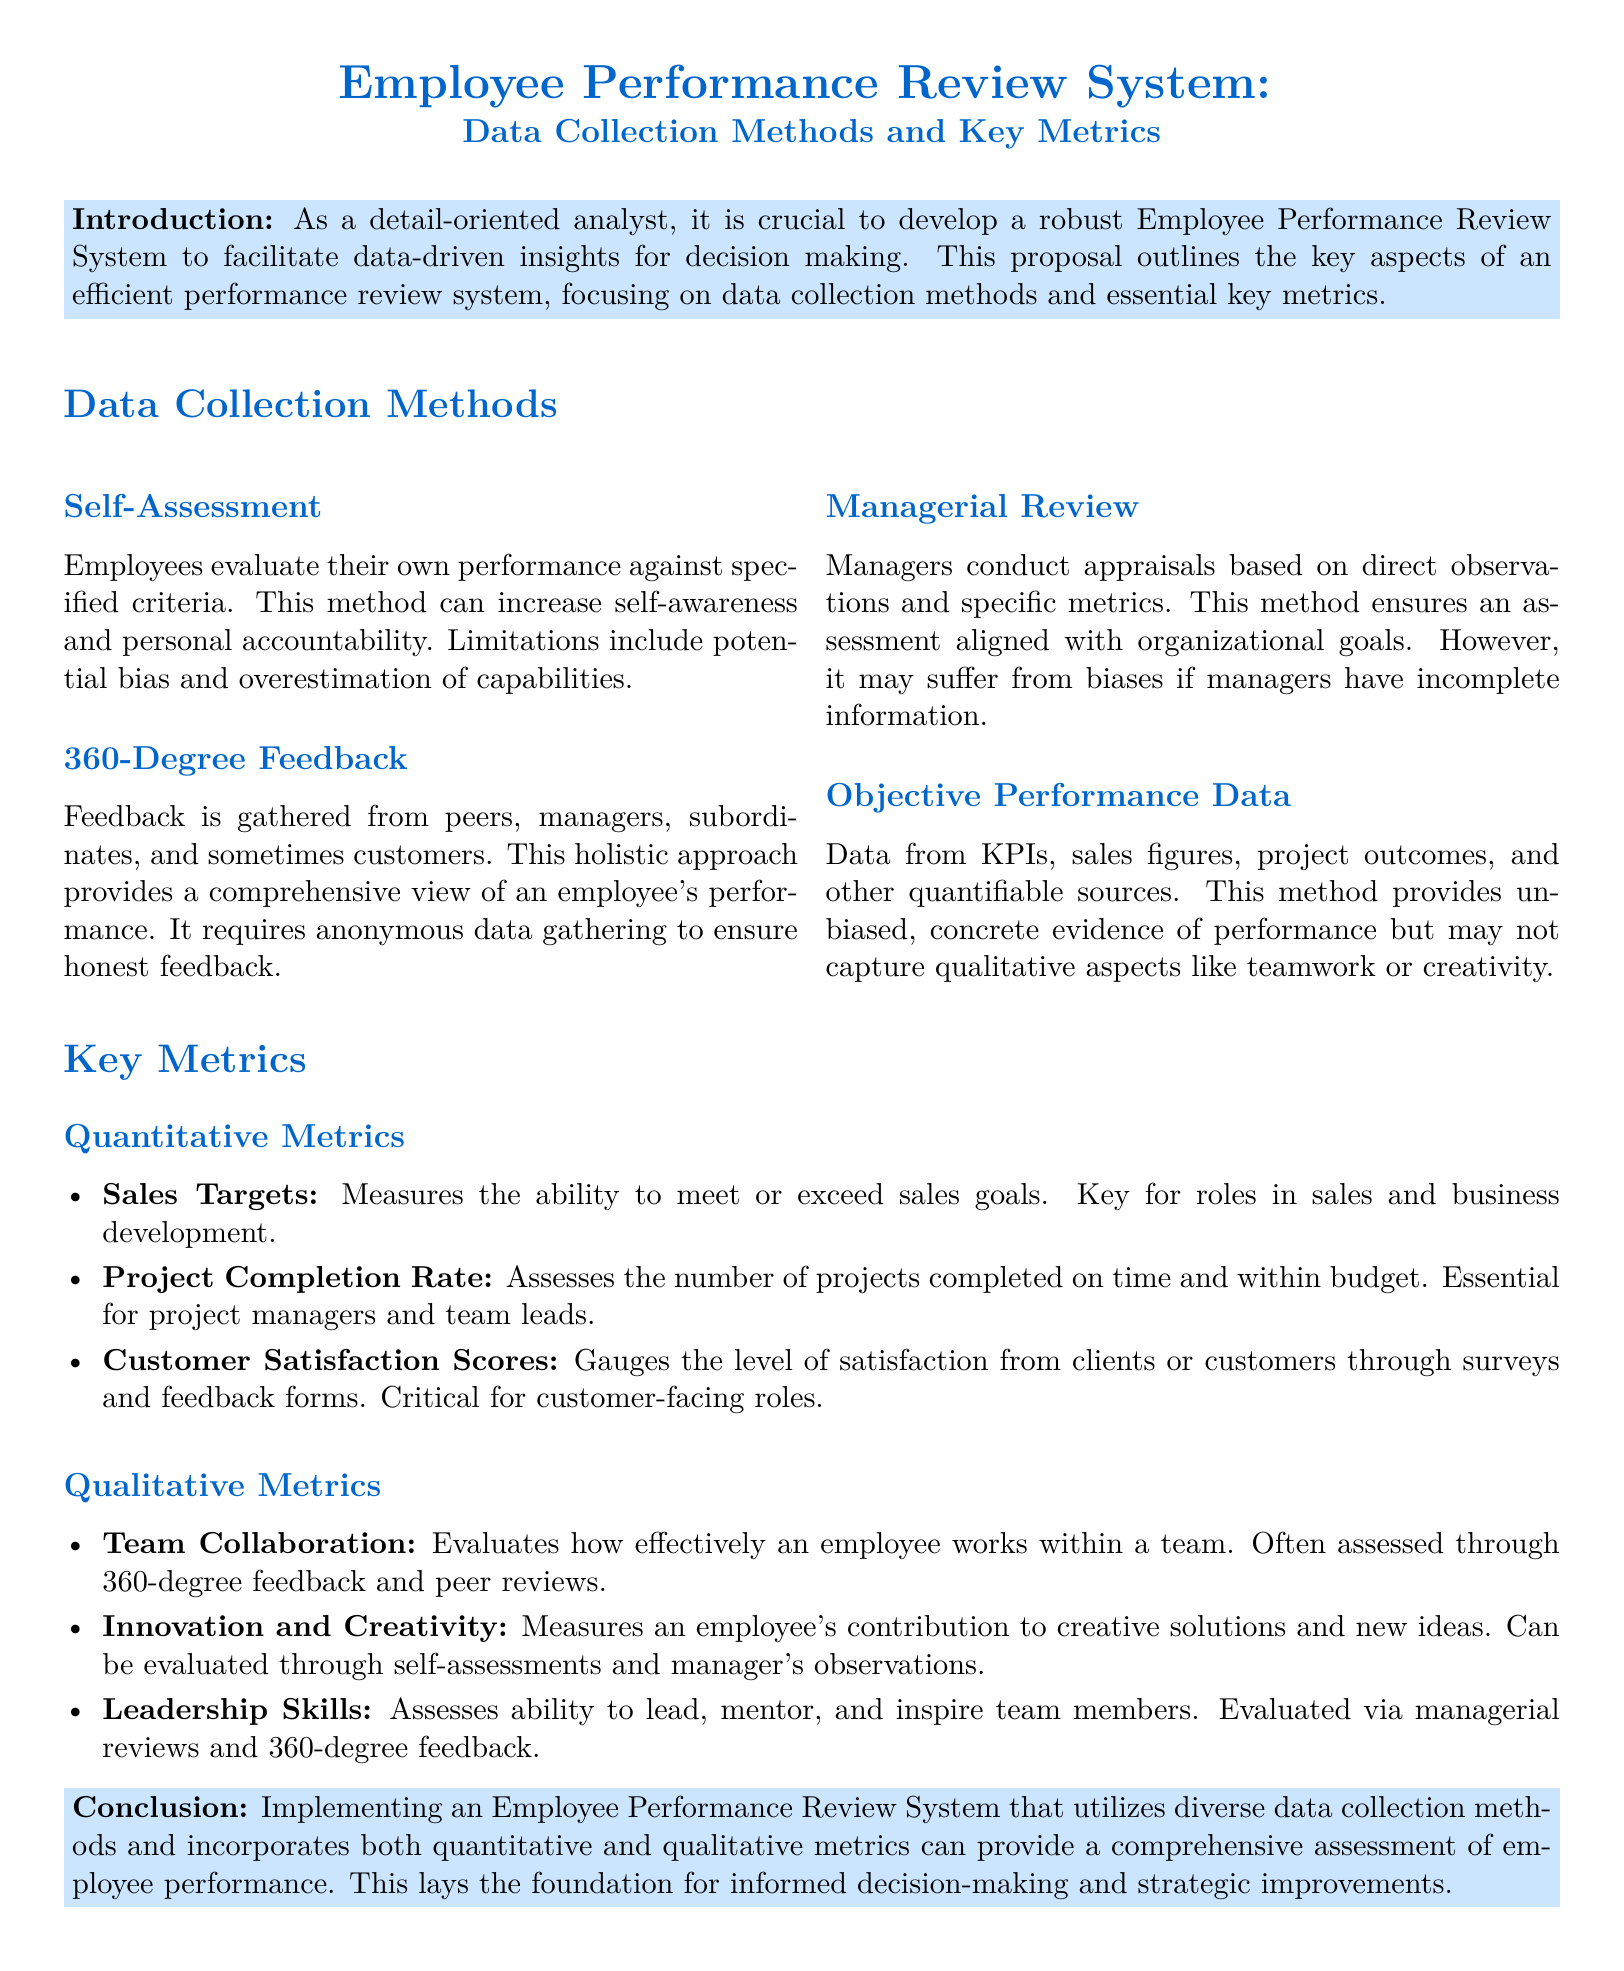What are the four data collection methods? The document lists four methods: Self-Assessment, 360-Degree Feedback, Managerial Review, and Objective Performance Data.
Answer: Self-Assessment, 360-Degree Feedback, Managerial Review, Objective Performance Data Which type of metrics does 'Sales Targets' fall under? The document classifies 'Sales Targets' as a quantitative metric.
Answer: Quantitative What limitation is associated with Self-Assessment? The document states that the limitation of Self-Assessment includes potential bias and overestimation of capabilities.
Answer: Potential bias and overestimation of capabilities What is one key qualitative metric mentioned for evaluating leadership? The document specifies 'Leadership Skills' as a key qualitative metric for assessment.
Answer: Leadership Skills How does the document suggest ensuring honest feedback in 360-Degree Feedback? The document suggests that anonymous data gathering ensures honest feedback in 360-Degree Feedback.
Answer: Anonymous data gathering What is the primary purpose of the introduction section? The introduction outlines the importance of developing a robust Employee Performance Review System for decision-making.
Answer: Developing a robust Employee Performance Review System for decision-making What type of document is presented here? This document is a proposal regarding an Employee Performance Review System.
Answer: Proposal How are Customer Satisfaction Scores categorized? The document categorizes Customer Satisfaction Scores as a quantitative metric.
Answer: Quantitative What method provides unbiased, concrete evidence of performance? The document indicates that Objective Performance Data provides unbiased, concrete evidence of performance.
Answer: Objective Performance Data 